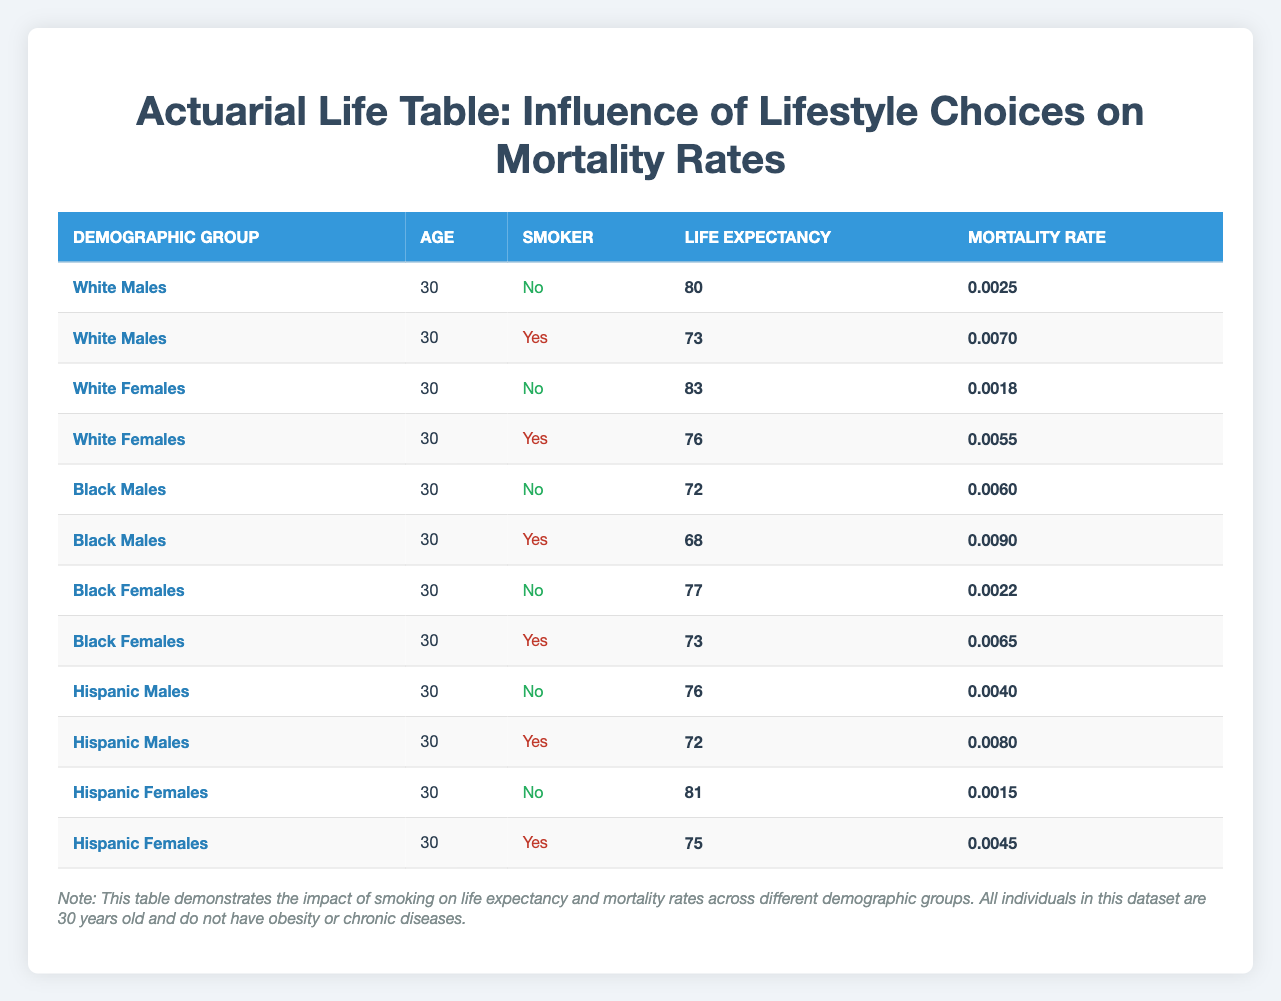What is the life expectancy for White Females who are non-smokers? From the table, locate the row for White Females with a non-smoker status. The life expectancy listed there is 83.
Answer: 83 What is the mortality rate for Black Males who are smokers? The table provides a row for Black Males who smoke, showing a mortality rate of 0.0090.
Answer: 0.0090 Is the life expectancy for Hispanic Females who are smokers higher than for Black Males who are smokers? The life expectancy for Hispanic Females who are smokers is 75, and for Black Males who smoke, it is 68. Since 75 is greater than 68, the statement is true.
Answer: Yes What is the difference in life expectancy between White Males who are non-smokers and Black Females who are non-smokers? For White Males who are non-smokers, the life expectancy is 80. For Black Females who are non-smokers, it is 77. The difference is calculated as 80 - 77 = 3.
Answer: 3 Are the mortality rates for smokers among Hispanic Males and Hispanic Females equal? Consulting the table, the mortality rate for Hispanic Males who are smokers is 0.0080, and for Hispanic Females, it is 0.0045. Since these values are not equal, the answer is no.
Answer: No What is the average life expectancy for smokers across all demographic groups? To find the average, first sum the life expectancies for smokers: 73 (White Males) + 76 (White Females) + 68 (Black Males) + 73 (Black Females) + 72 (Hispanic Males) + 75 (Hispanic Females) = 437. Since there are 6 data points, the average is 437 / 6 = 72.83.
Answer: 72.83 For which demographic group is the mortality rate highest among non-smokers? Comparing the mortality rates for non-smokers: 0.0025 (White Males), 0.0018 (White Females), 0.0060 (Black Males), 0.0022 (Black Females), and 0.0040 (Hispanic Males), the highest mortality rate is 0.0060 for Black Males.
Answer: Black Males What is the combined mortality rate for non-smoking Black Females and Hispanic Females? The mortality rate for non-smoking Black Females is 0.0022, and for non-smoking Hispanic Females, it is 0.0015. The combined rate is calculated as 0.0022 + 0.0015 = 0.0037.
Answer: 0.0037 